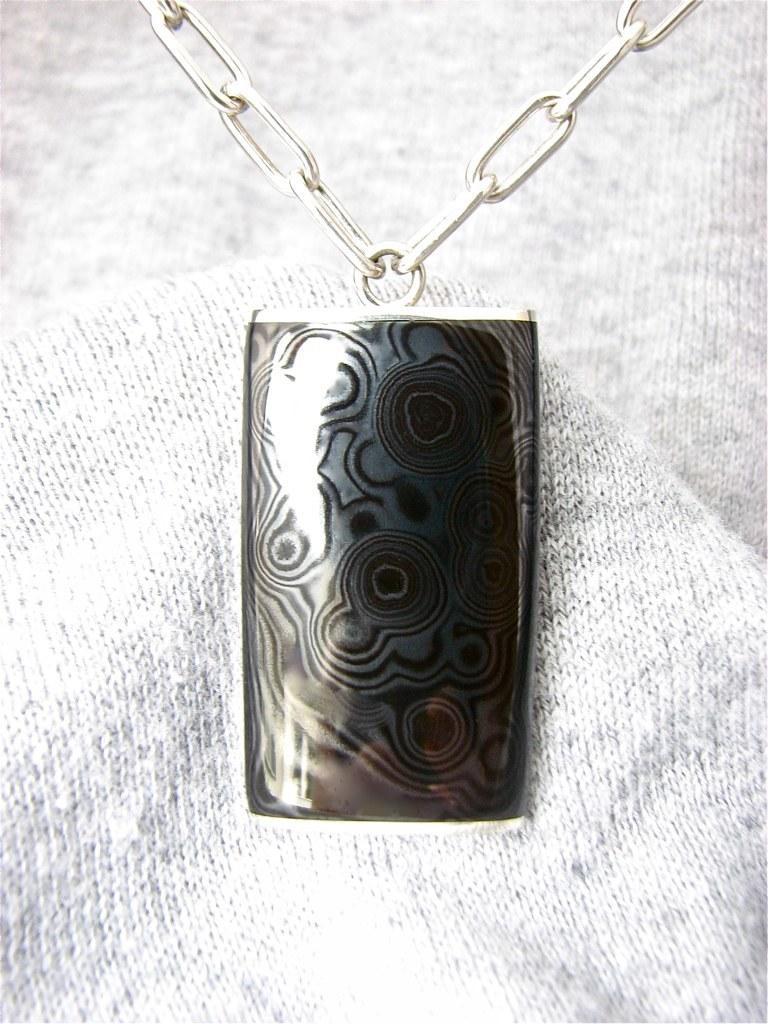Describe this image in one or two sentences. In this image I can see the chain and the locket. It is on the white and ash color cloth. 